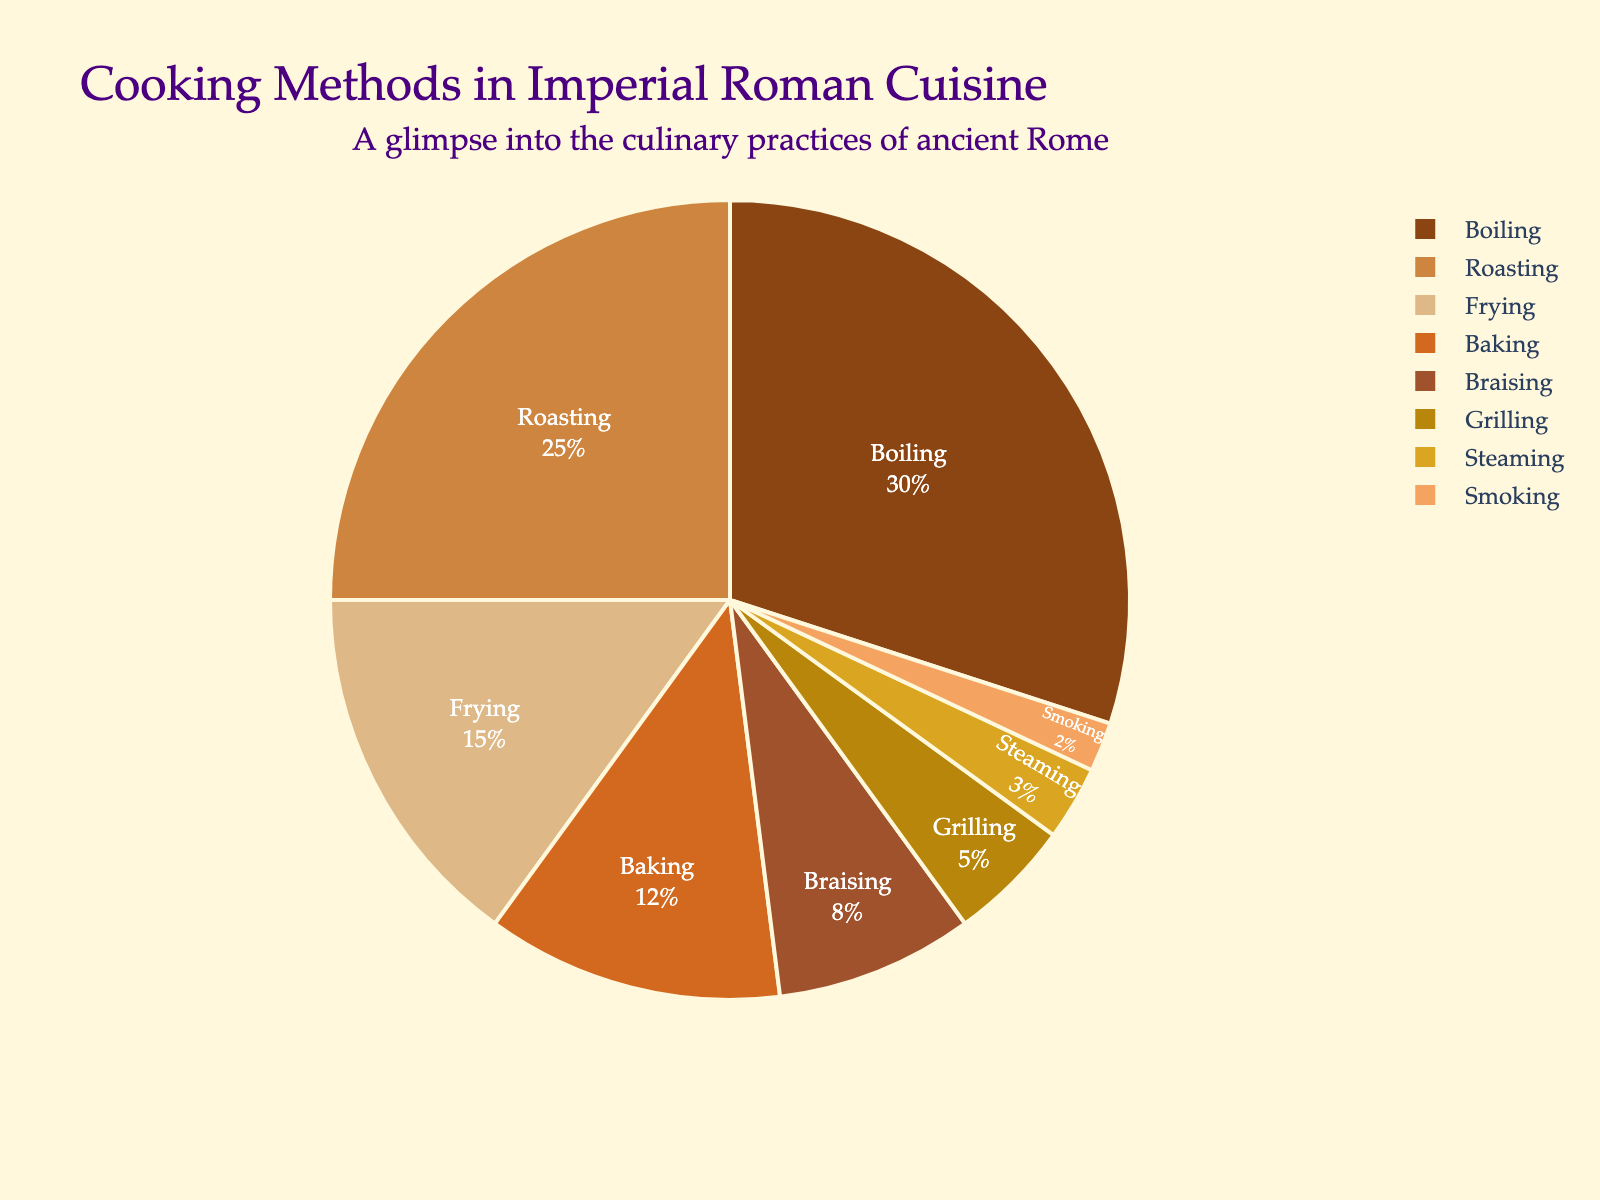What's the most common cooking method used in Imperial Roman cuisine? By looking at the pie chart, the largest segment represents the cooking method with the highest percentage.
Answer: Boiling What's the second most common cooking method in the chart? To find the second largest segment, we look for the next largest slice in the pie chart after boiling.
Answer: Roasting What is the total percentage of methods that involve direct heat (roasting, grilling, smoking)? Sum the percentages of roasting (25%), grilling (5%), and smoking (2%). 25 + 5 + 2 = 32
Answer: 32% Which cooking method is least common in Imperial Roman cuisine? The smallest segment in the pie chart represents the least common cooking method.
Answer: Smoking How much more common is boiling compared to frying? Subtract the percentage of frying (15%) from the percentage of boiling (30%). 30 - 15 = 15
Answer: 15% What percentage of cooking methods involves moist heat (boiling, braising, steaming)? Sum the percentages of boiling (30%), braising (8%), and steaming (3%). 30 + 8 + 3 = 41
Answer: 41% Is baking more or less common than frying? Compare the segments for baking and frying. Baking is 12%, and frying is 15%.
Answer: Less Which cooking methods together make up more than 50% of the total? Sum the percentages starting from the highest: boiling (30%) + roasting (25%) = 55%.
Answer: Boiling and Roasting Is braising more common than grilling? Compare the percentage slices for braising (8%) and grilling (5%).
Answer: Yes Combine the percentages of the two least common methods. What percentage do they form? Add the percentages of the two smallest segments, steaming (3%) and smoking (2%). 3 + 2 = 5
Answer: 5% 